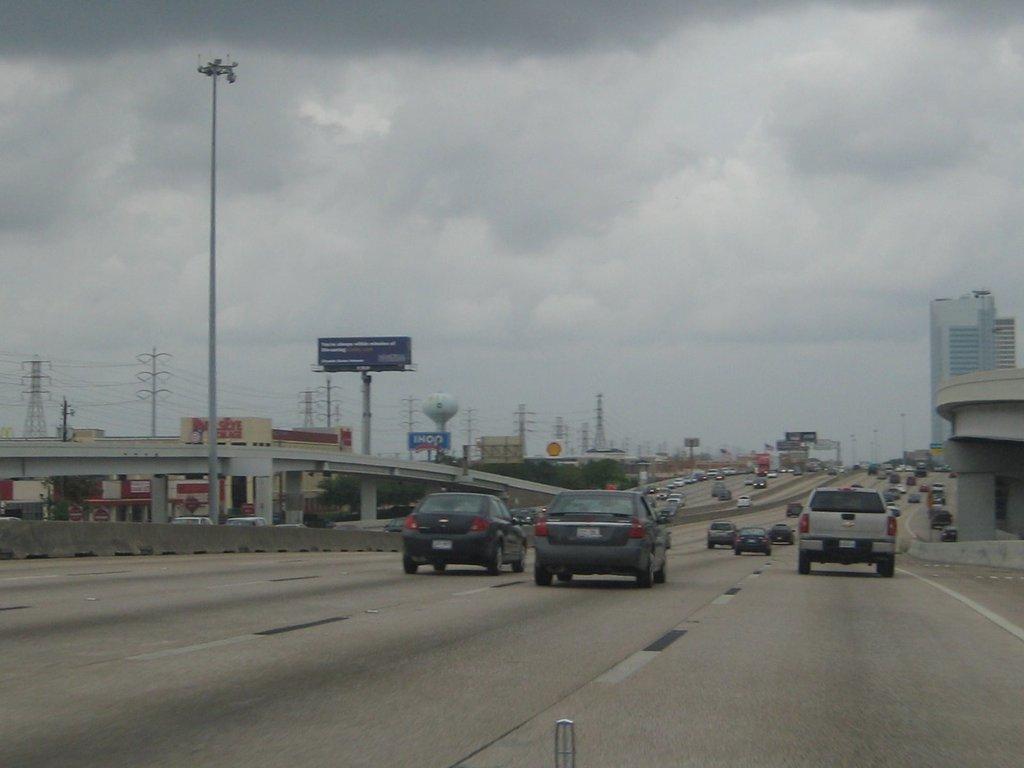Could you give a brief overview of what you see in this image? This image is clicked outside. There is sky at the top. There is a bridge in the middle. There are so many vehicles moving on the road. There are buildings in the middle. There is a pole on the left side. 